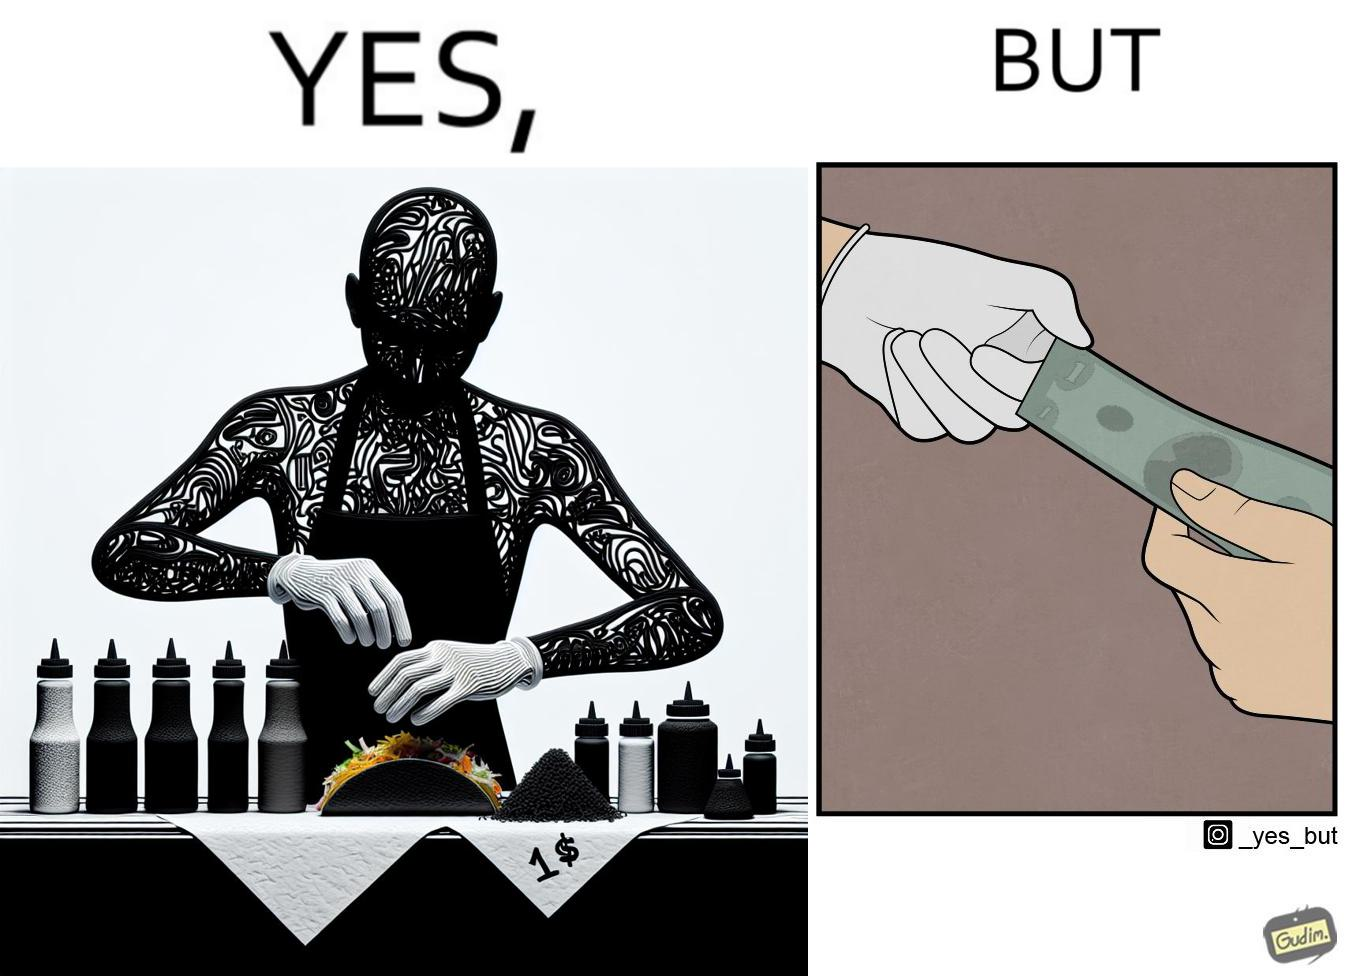Describe what you see in this image. The image is satirical because the intention of wearing a glove while preparing food is to not let any germs and dirt from our hands get into the food, people do other tasks like collecting money from the customer wearing the same gloves and thus making the gloves themselves dirty. 